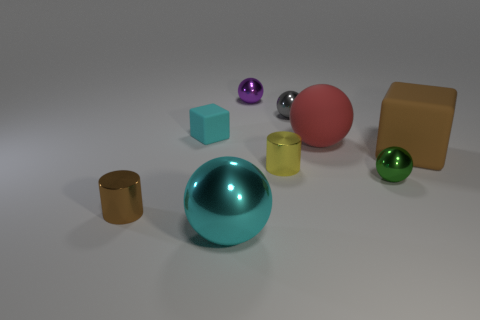What is the material of the small object that is the same color as the large rubber cube?
Offer a very short reply. Metal. There is a large red matte object; is its shape the same as the large metallic object that is in front of the big matte cube?
Offer a very short reply. Yes. What material is the cyan thing behind the brown matte object to the right of the yellow cylinder made of?
Your answer should be very brief. Rubber. What number of other things are the same shape as the purple metal object?
Give a very brief answer. 4. There is a cyan object in front of the small cyan matte object; is its shape the same as the red thing that is left of the small green metal ball?
Ensure brevity in your answer.  Yes. What material is the tiny brown cylinder?
Make the answer very short. Metal. What material is the brown thing that is on the right side of the big red rubber ball?
Give a very brief answer. Rubber. Is there anything else that has the same color as the large matte sphere?
Ensure brevity in your answer.  No. There is a purple thing that is the same material as the gray sphere; what size is it?
Offer a terse response. Small. How many big things are red things or cyan objects?
Your answer should be compact. 2. 